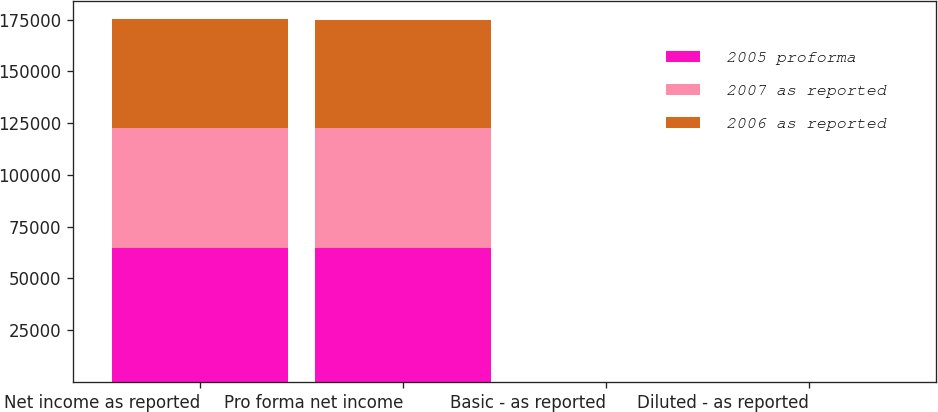Convert chart. <chart><loc_0><loc_0><loc_500><loc_500><stacked_bar_chart><ecel><fcel>Net income as reported<fcel>Pro forma net income<fcel>Basic - as reported<fcel>Diluted - as reported<nl><fcel>2005 proforma<fcel>64731<fcel>64731<fcel>0.65<fcel>0.64<nl><fcel>2007 as reported<fcel>57809<fcel>57809<fcel>0.57<fcel>0.56<nl><fcel>2006 as reported<fcel>52773<fcel>52089<fcel>0.52<fcel>0.51<nl></chart> 